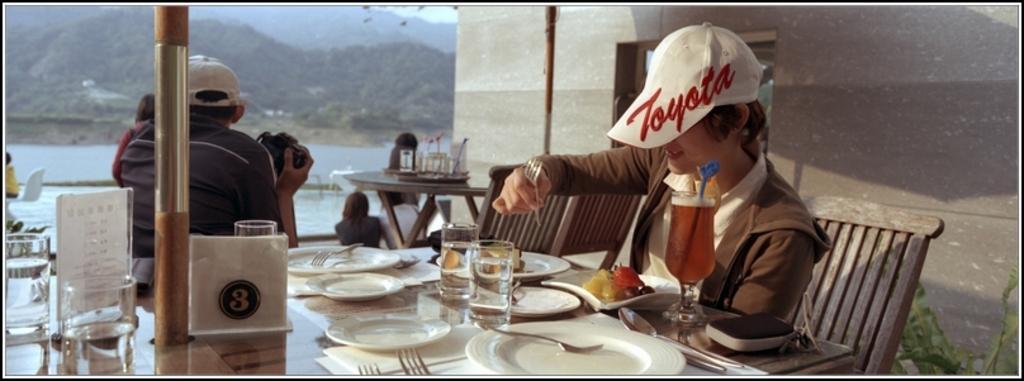Please provide a concise description of this image. As we can see in the image there are trees, water, wall, few people here and there, chairs and tables. On table there are plates, glass, tissues and the man who is sitting here is holding camera. 